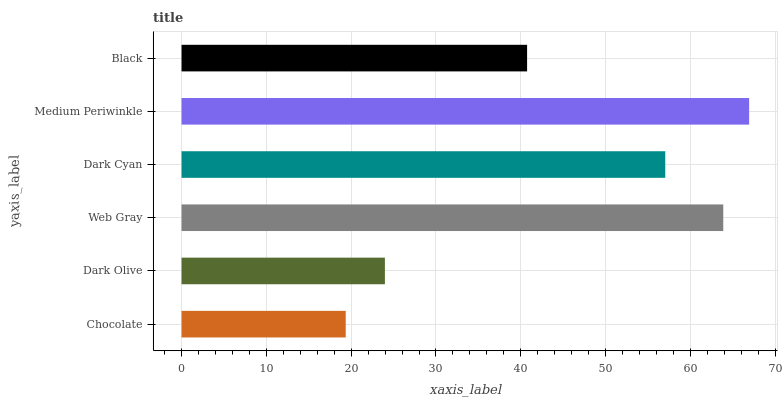Is Chocolate the minimum?
Answer yes or no. Yes. Is Medium Periwinkle the maximum?
Answer yes or no. Yes. Is Dark Olive the minimum?
Answer yes or no. No. Is Dark Olive the maximum?
Answer yes or no. No. Is Dark Olive greater than Chocolate?
Answer yes or no. Yes. Is Chocolate less than Dark Olive?
Answer yes or no. Yes. Is Chocolate greater than Dark Olive?
Answer yes or no. No. Is Dark Olive less than Chocolate?
Answer yes or no. No. Is Dark Cyan the high median?
Answer yes or no. Yes. Is Black the low median?
Answer yes or no. Yes. Is Web Gray the high median?
Answer yes or no. No. Is Medium Periwinkle the low median?
Answer yes or no. No. 